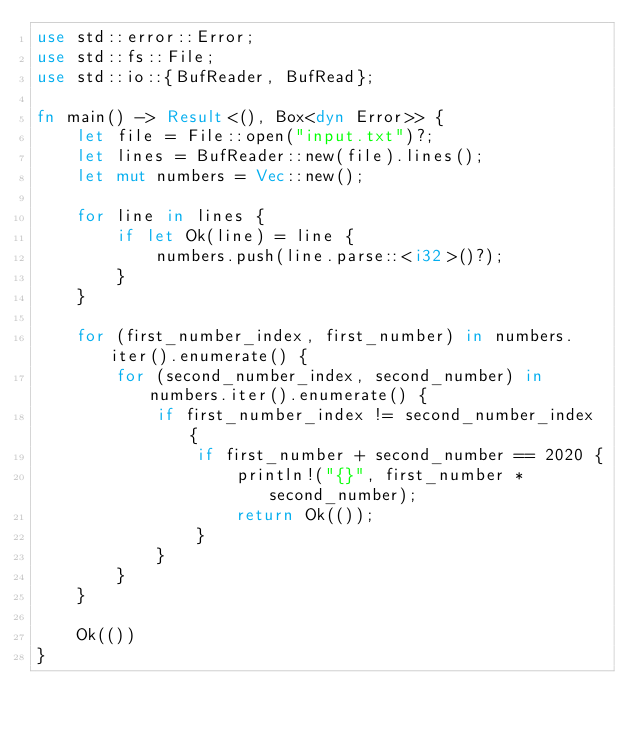<code> <loc_0><loc_0><loc_500><loc_500><_Rust_>use std::error::Error;
use std::fs::File;
use std::io::{BufReader, BufRead};

fn main() -> Result<(), Box<dyn Error>> {
    let file = File::open("input.txt")?;
    let lines = BufReader::new(file).lines();
    let mut numbers = Vec::new();

    for line in lines {
        if let Ok(line) = line {
            numbers.push(line.parse::<i32>()?);
        }
    }

    for (first_number_index, first_number) in numbers.iter().enumerate() {
        for (second_number_index, second_number) in numbers.iter().enumerate() {
            if first_number_index != second_number_index {
                if first_number + second_number == 2020 {
                    println!("{}", first_number * second_number);
                    return Ok(());
                }
            }
        }
    }

    Ok(())
}</code> 